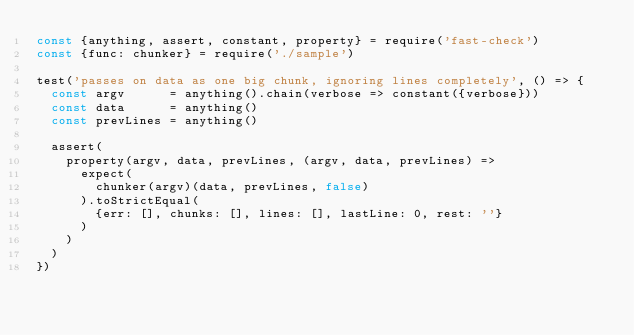<code> <loc_0><loc_0><loc_500><loc_500><_JavaScript_>const {anything, assert, constant, property} = require('fast-check')
const {func: chunker} = require('./sample')

test('passes on data as one big chunk, ignoring lines completely', () => {
  const argv      = anything().chain(verbose => constant({verbose}))
  const data      = anything()
  const prevLines = anything()

  assert(
    property(argv, data, prevLines, (argv, data, prevLines) =>
      expect(
        chunker(argv)(data, prevLines, false)
      ).toStrictEqual(
        {err: [], chunks: [], lines: [], lastLine: 0, rest: ''}
      )
    )
  )
})</code> 